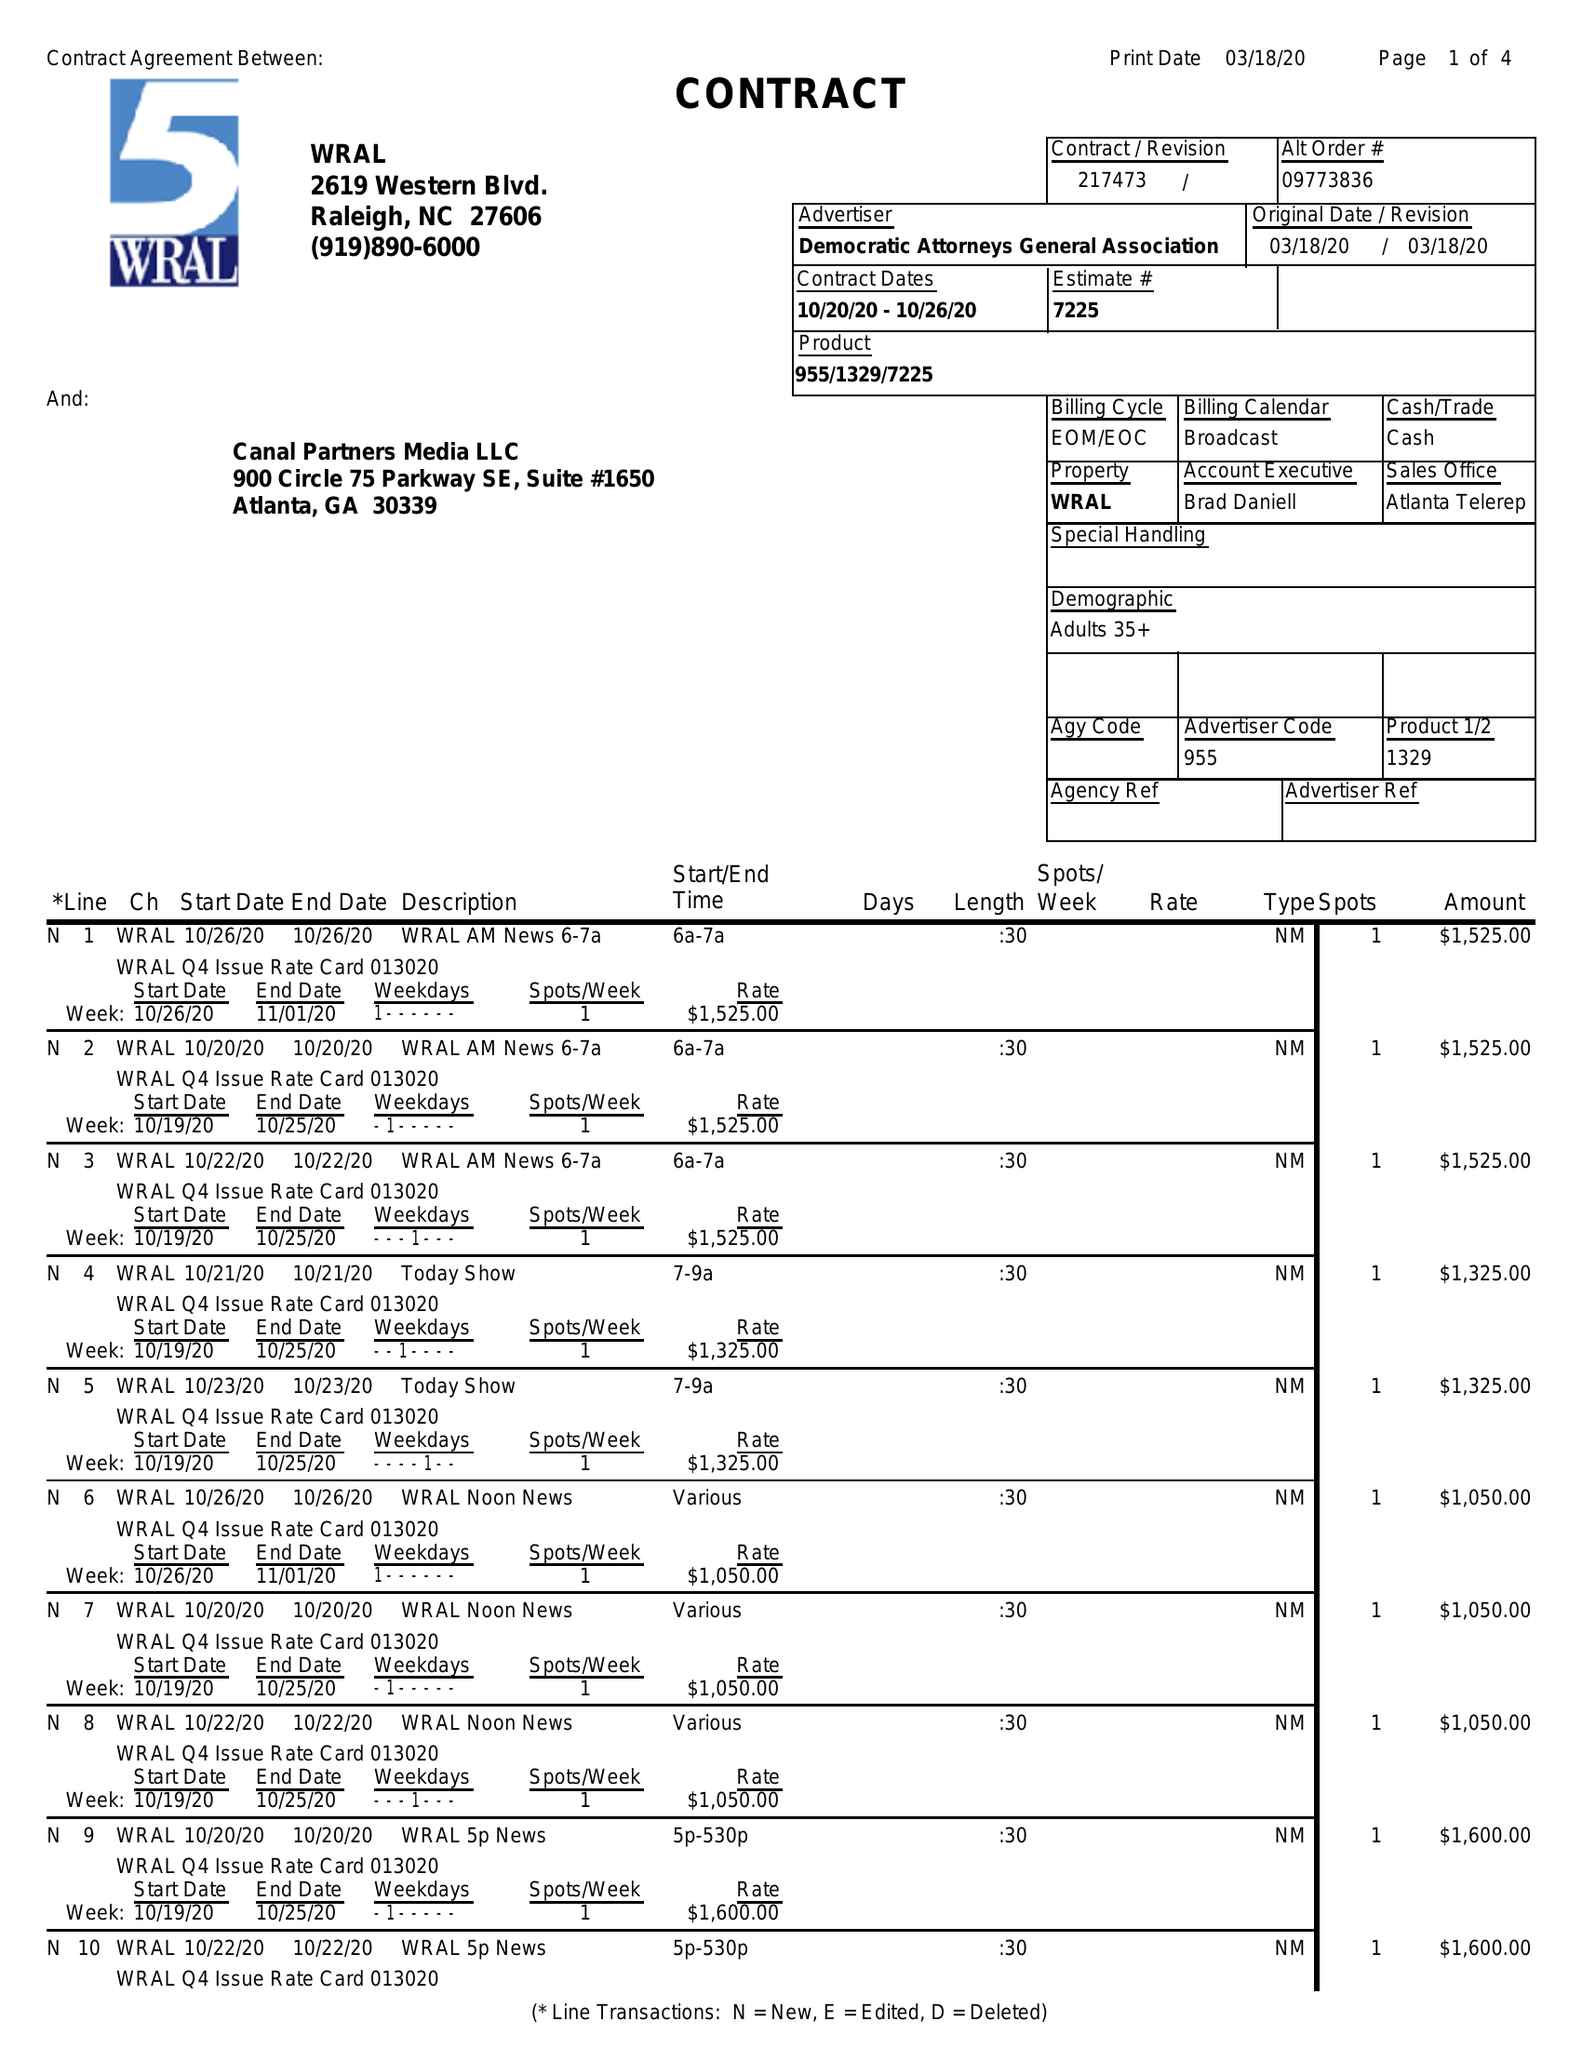What is the value for the flight_to?
Answer the question using a single word or phrase. 10/26/20 